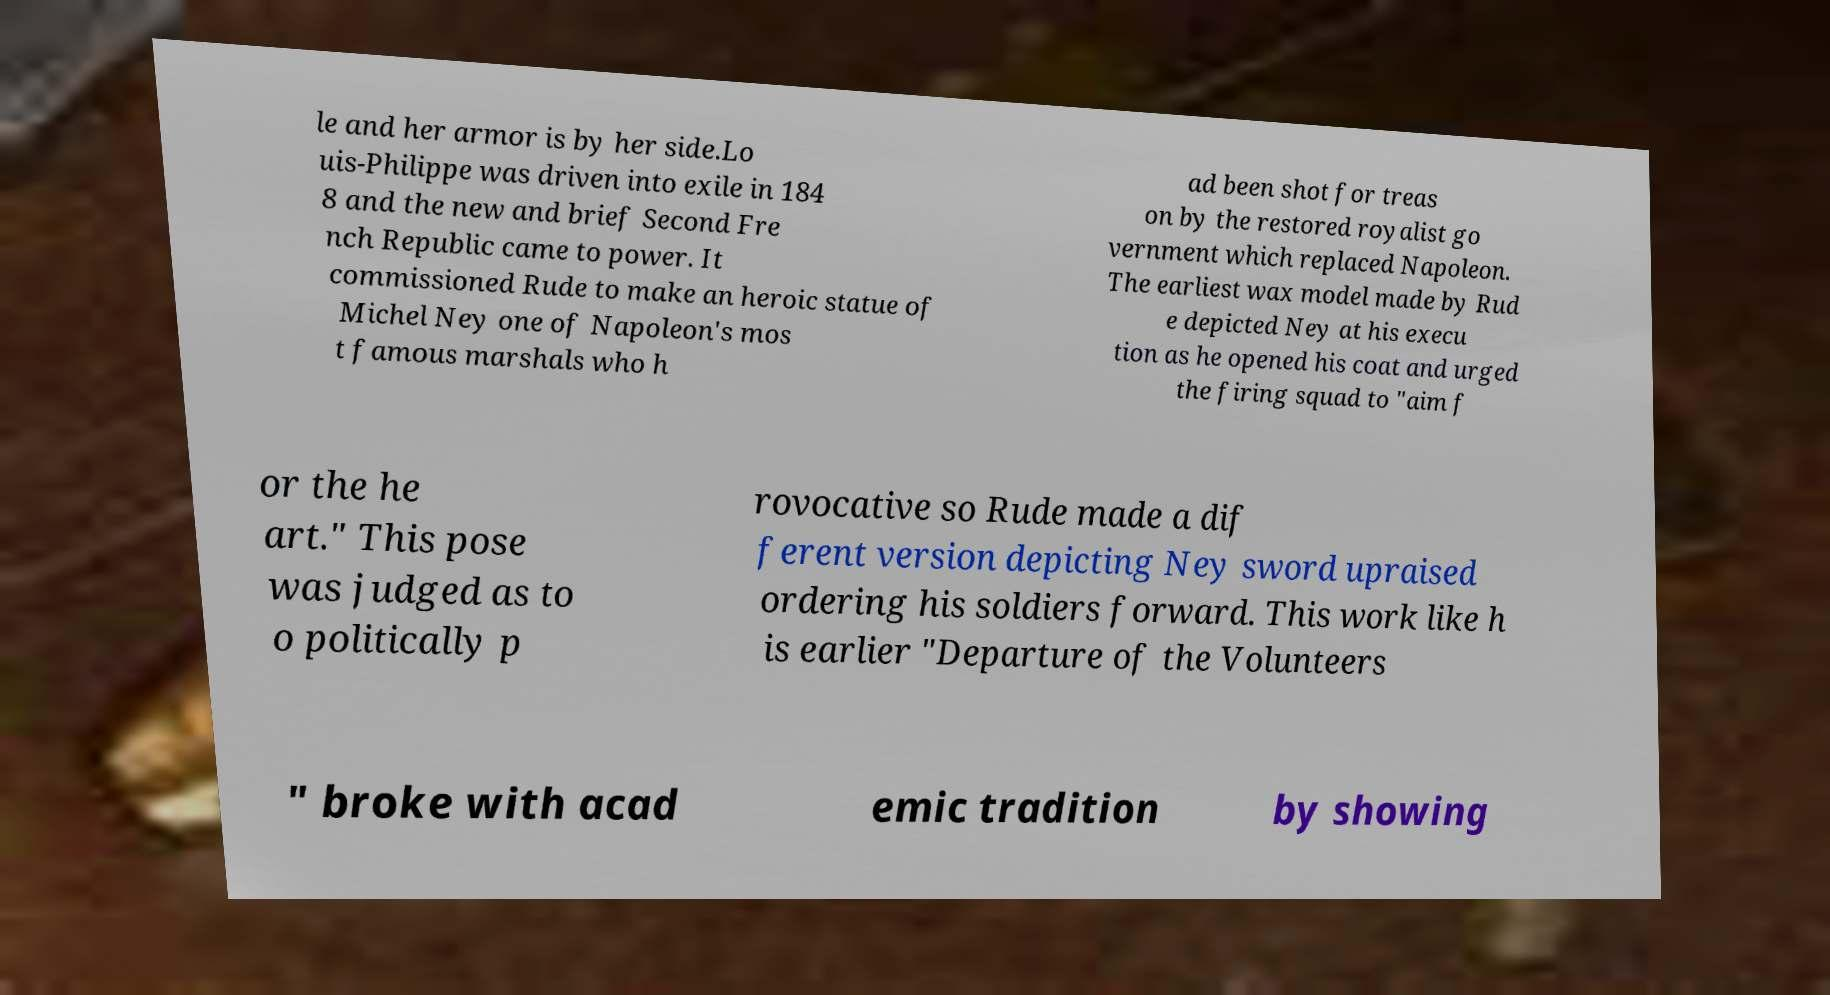What messages or text are displayed in this image? I need them in a readable, typed format. le and her armor is by her side.Lo uis-Philippe was driven into exile in 184 8 and the new and brief Second Fre nch Republic came to power. It commissioned Rude to make an heroic statue of Michel Ney one of Napoleon's mos t famous marshals who h ad been shot for treas on by the restored royalist go vernment which replaced Napoleon. The earliest wax model made by Rud e depicted Ney at his execu tion as he opened his coat and urged the firing squad to "aim f or the he art." This pose was judged as to o politically p rovocative so Rude made a dif ferent version depicting Ney sword upraised ordering his soldiers forward. This work like h is earlier "Departure of the Volunteers " broke with acad emic tradition by showing 